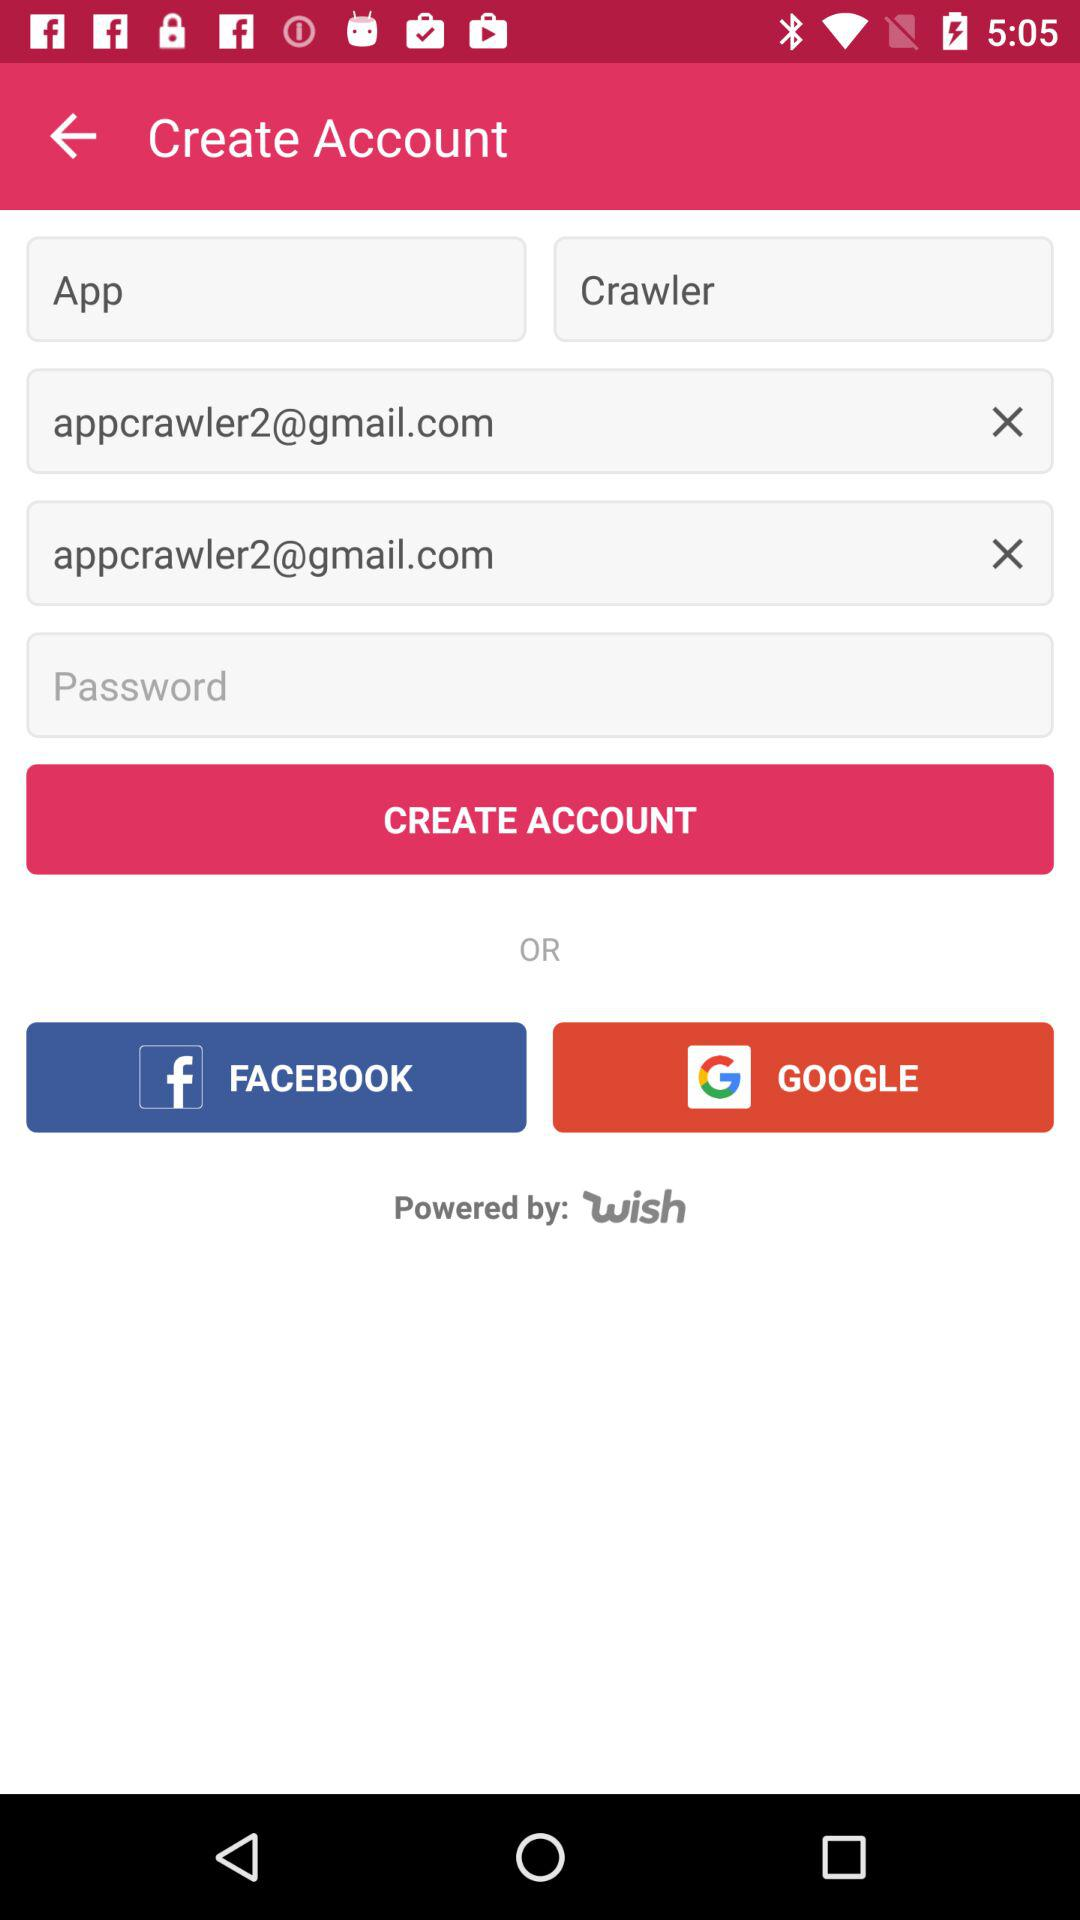How many text inputs are there for the email address?
Answer the question using a single word or phrase. 2 